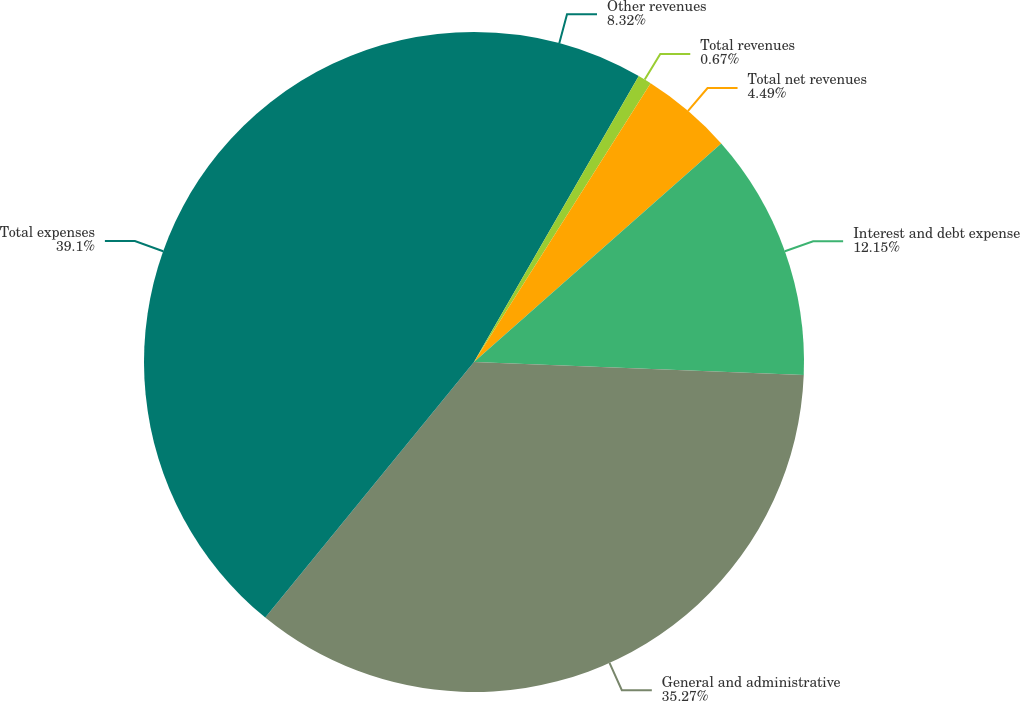Convert chart. <chart><loc_0><loc_0><loc_500><loc_500><pie_chart><fcel>Other revenues<fcel>Total revenues<fcel>Total net revenues<fcel>Interest and debt expense<fcel>General and administrative<fcel>Total expenses<nl><fcel>8.32%<fcel>0.67%<fcel>4.49%<fcel>12.15%<fcel>35.27%<fcel>39.1%<nl></chart> 